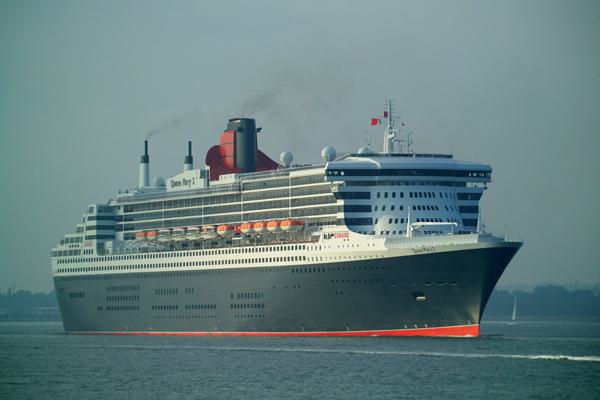How many unicorns would there be in the image after no unicorn was removed in the image? 0 